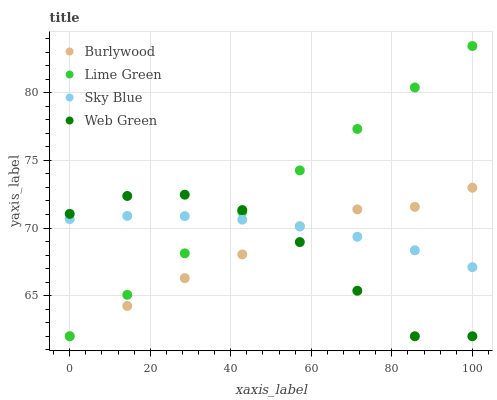Does Web Green have the minimum area under the curve?
Answer yes or no. Yes. Does Lime Green have the maximum area under the curve?
Answer yes or no. Yes. Does Sky Blue have the minimum area under the curve?
Answer yes or no. No. Does Sky Blue have the maximum area under the curve?
Answer yes or no. No. Is Lime Green the smoothest?
Answer yes or no. Yes. Is Web Green the roughest?
Answer yes or no. Yes. Is Sky Blue the smoothest?
Answer yes or no. No. Is Sky Blue the roughest?
Answer yes or no. No. Does Burlywood have the lowest value?
Answer yes or no. Yes. Does Sky Blue have the lowest value?
Answer yes or no. No. Does Lime Green have the highest value?
Answer yes or no. Yes. Does Sky Blue have the highest value?
Answer yes or no. No. Does Sky Blue intersect Web Green?
Answer yes or no. Yes. Is Sky Blue less than Web Green?
Answer yes or no. No. Is Sky Blue greater than Web Green?
Answer yes or no. No. 